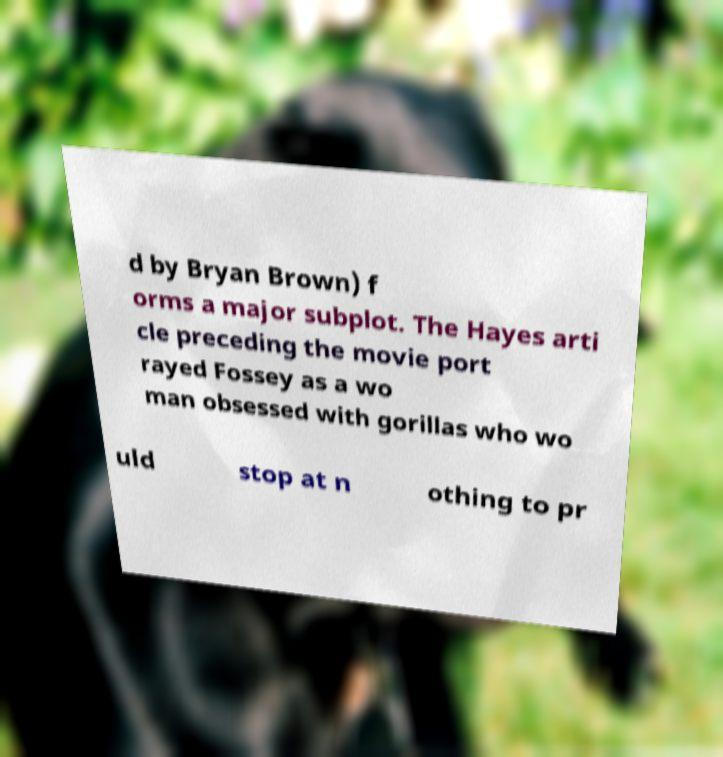What messages or text are displayed in this image? I need them in a readable, typed format. d by Bryan Brown) f orms a major subplot. The Hayes arti cle preceding the movie port rayed Fossey as a wo man obsessed with gorillas who wo uld stop at n othing to pr 